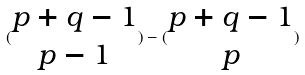<formula> <loc_0><loc_0><loc_500><loc_500>( \begin{matrix} p + q - 1 \\ p - 1 \end{matrix} ) - ( \begin{matrix} p + q - 1 \\ p \end{matrix} )</formula> 